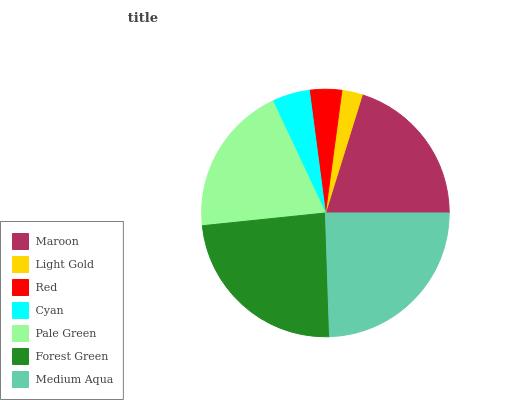Is Light Gold the minimum?
Answer yes or no. Yes. Is Medium Aqua the maximum?
Answer yes or no. Yes. Is Red the minimum?
Answer yes or no. No. Is Red the maximum?
Answer yes or no. No. Is Red greater than Light Gold?
Answer yes or no. Yes. Is Light Gold less than Red?
Answer yes or no. Yes. Is Light Gold greater than Red?
Answer yes or no. No. Is Red less than Light Gold?
Answer yes or no. No. Is Pale Green the high median?
Answer yes or no. Yes. Is Pale Green the low median?
Answer yes or no. Yes. Is Light Gold the high median?
Answer yes or no. No. Is Red the low median?
Answer yes or no. No. 